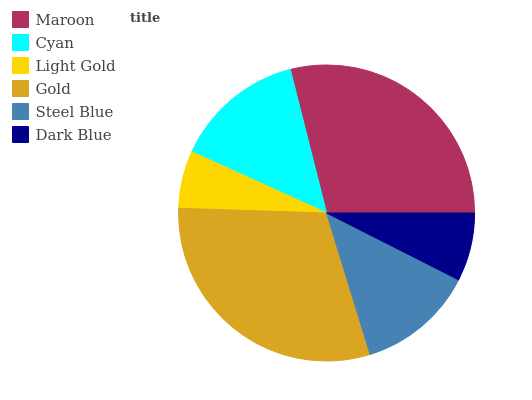Is Light Gold the minimum?
Answer yes or no. Yes. Is Gold the maximum?
Answer yes or no. Yes. Is Cyan the minimum?
Answer yes or no. No. Is Cyan the maximum?
Answer yes or no. No. Is Maroon greater than Cyan?
Answer yes or no. Yes. Is Cyan less than Maroon?
Answer yes or no. Yes. Is Cyan greater than Maroon?
Answer yes or no. No. Is Maroon less than Cyan?
Answer yes or no. No. Is Cyan the high median?
Answer yes or no. Yes. Is Steel Blue the low median?
Answer yes or no. Yes. Is Maroon the high median?
Answer yes or no. No. Is Maroon the low median?
Answer yes or no. No. 